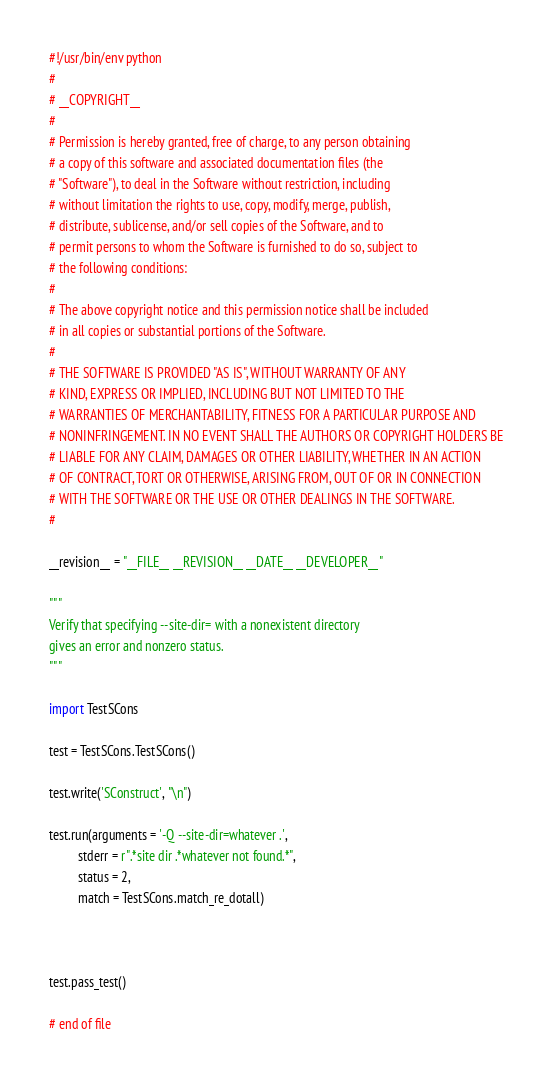Convert code to text. <code><loc_0><loc_0><loc_500><loc_500><_Python_>#!/usr/bin/env python
#
# __COPYRIGHT__
#
# Permission is hereby granted, free of charge, to any person obtaining
# a copy of this software and associated documentation files (the
# "Software"), to deal in the Software without restriction, including
# without limitation the rights to use, copy, modify, merge, publish,
# distribute, sublicense, and/or sell copies of the Software, and to
# permit persons to whom the Software is furnished to do so, subject to
# the following conditions:
#
# The above copyright notice and this permission notice shall be included
# in all copies or substantial portions of the Software.
#
# THE SOFTWARE IS PROVIDED "AS IS", WITHOUT WARRANTY OF ANY
# KIND, EXPRESS OR IMPLIED, INCLUDING BUT NOT LIMITED TO THE
# WARRANTIES OF MERCHANTABILITY, FITNESS FOR A PARTICULAR PURPOSE AND
# NONINFRINGEMENT. IN NO EVENT SHALL THE AUTHORS OR COPYRIGHT HOLDERS BE
# LIABLE FOR ANY CLAIM, DAMAGES OR OTHER LIABILITY, WHETHER IN AN ACTION
# OF CONTRACT, TORT OR OTHERWISE, ARISING FROM, OUT OF OR IN CONNECTION
# WITH THE SOFTWARE OR THE USE OR OTHER DEALINGS IN THE SOFTWARE.
#

__revision__ = "__FILE__ __REVISION__ __DATE__ __DEVELOPER__"

"""
Verify that specifying --site-dir= with a nonexistent directory
gives an error and nonzero status.
"""

import TestSCons

test = TestSCons.TestSCons()

test.write('SConstruct', "\n")

test.run(arguments = '-Q --site-dir=whatever .',
         stderr = r".*site dir .*whatever not found.*",
         status = 2, 
         match = TestSCons.match_re_dotall)



test.pass_test()

# end of file
</code> 